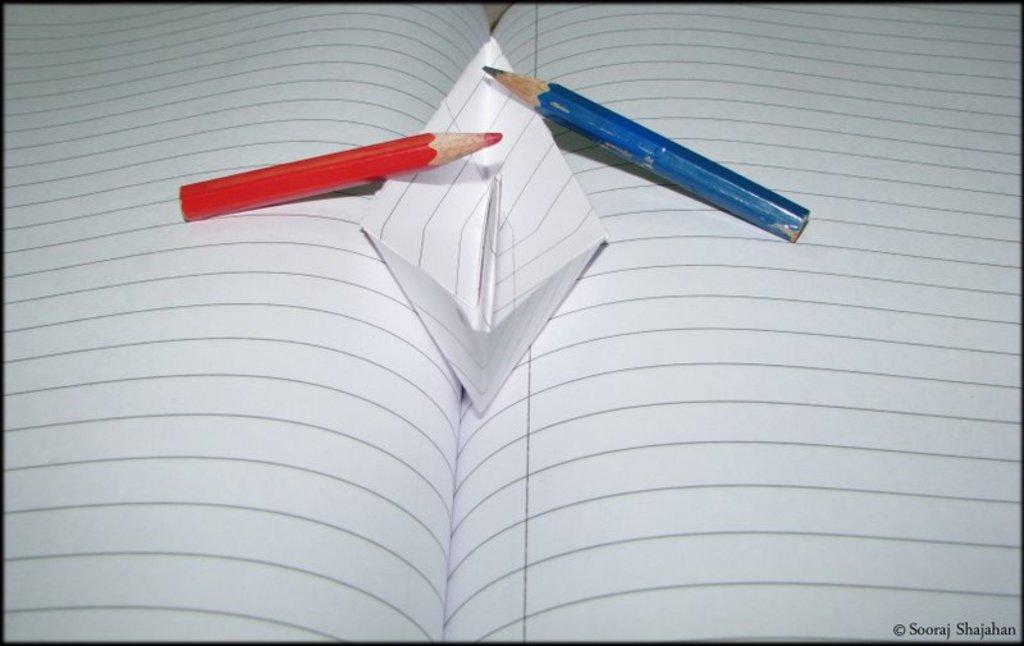Can you describe this image briefly? In this image we can see an opened book. On the book there are pencils and a boat made with paper. In the right bottom corner something is written. 